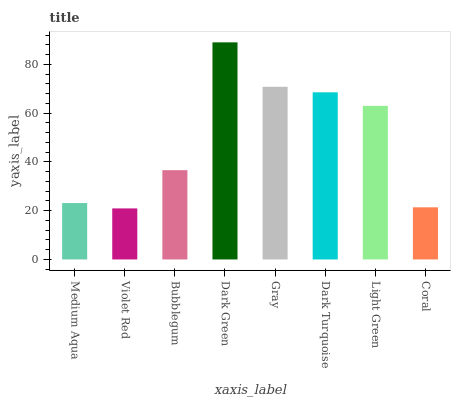Is Violet Red the minimum?
Answer yes or no. Yes. Is Dark Green the maximum?
Answer yes or no. Yes. Is Bubblegum the minimum?
Answer yes or no. No. Is Bubblegum the maximum?
Answer yes or no. No. Is Bubblegum greater than Violet Red?
Answer yes or no. Yes. Is Violet Red less than Bubblegum?
Answer yes or no. Yes. Is Violet Red greater than Bubblegum?
Answer yes or no. No. Is Bubblegum less than Violet Red?
Answer yes or no. No. Is Light Green the high median?
Answer yes or no. Yes. Is Bubblegum the low median?
Answer yes or no. Yes. Is Coral the high median?
Answer yes or no. No. Is Medium Aqua the low median?
Answer yes or no. No. 